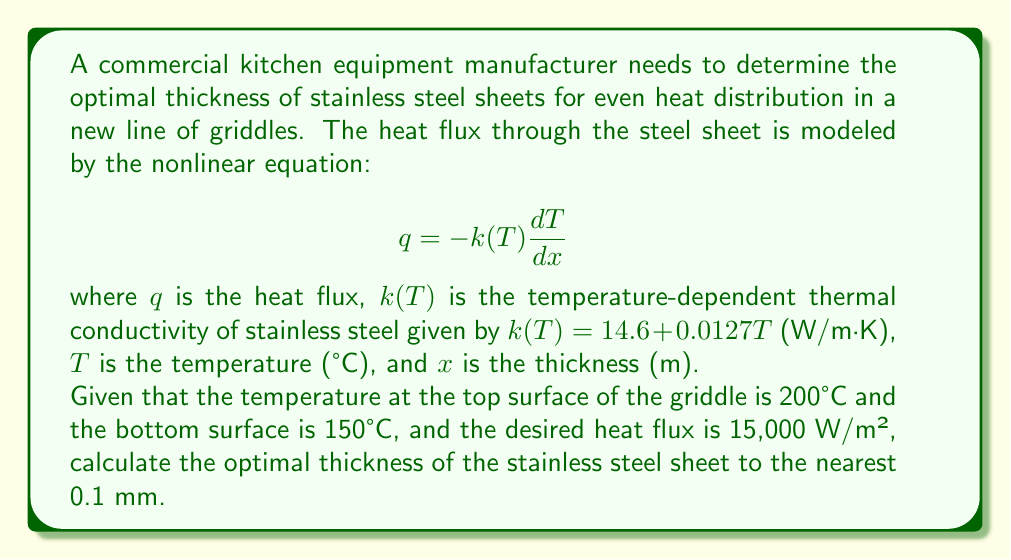Solve this math problem. To solve this problem, we need to integrate the nonlinear heat equation across the thickness of the steel sheet. Here's the step-by-step solution:

1) The heat equation is given by:
   $$q = -k(T) \frac{dT}{dx}$$

2) Rearranging the equation:
   $$dx = -\frac{k(T)}{q} dT$$

3) Integrating both sides from the bottom surface (x = 0, T = 150°C) to the top surface (x = L, T = 200°C):
   $$\int_0^L dx = -\frac{1}{q} \int_{150}^{200} k(T) dT$$

4) Substituting the expression for k(T):
   $$L = -\frac{1}{q} \int_{150}^{200} (14.6 + 0.0127T) dT$$

5) Evaluating the integral:
   $$L = -\frac{1}{q} [14.6T + 0.00635T^2]_{150}^{200}$$

6) Substituting the values:
   $$L = -\frac{1}{15000} [(14.6 * 200 + 0.00635 * 200^2) - (14.6 * 150 + 0.00635 * 150^2)]$$

7) Simplifying:
   $$L = -\frac{1}{15000} [3174 - 2336.25] = -\frac{837.75}{15000}$$

8) Calculating the final result:
   $$L = 0.05585 \text{ m} = 55.85 \text{ mm}$$

9) Rounding to the nearest 0.1 mm:
   $$L \approx 55.9 \text{ mm}$$
Answer: 55.9 mm 